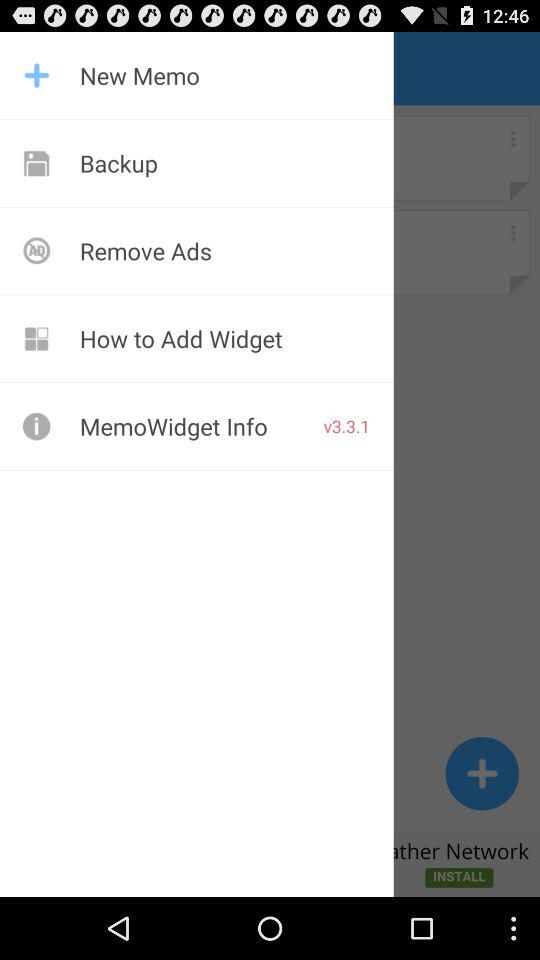What version is this? The version is v3.3.1. 